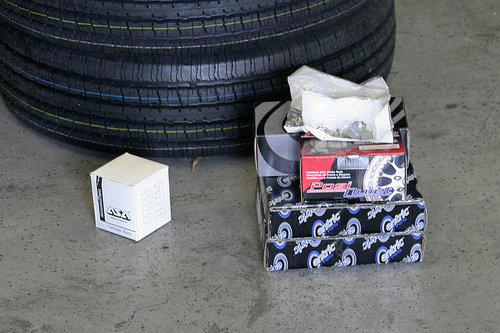<image>
Is there a box in front of the tire? Yes. The box is positioned in front of the tire, appearing closer to the camera viewpoint. 